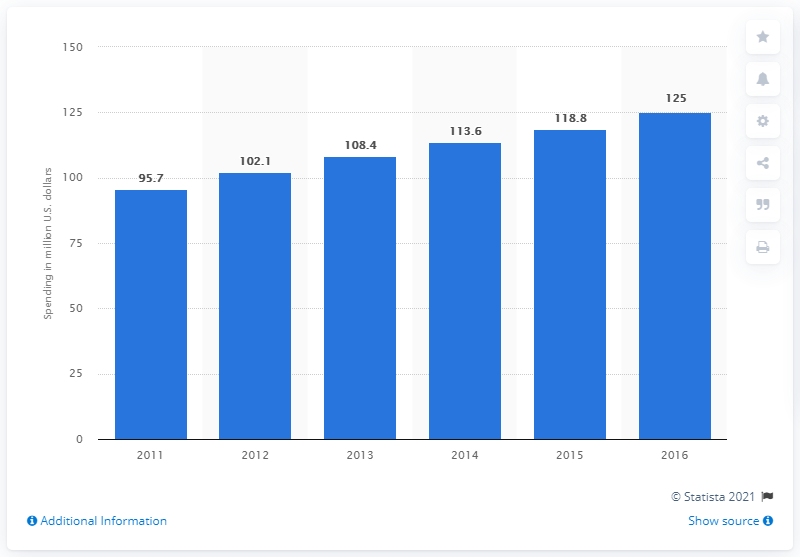Highlight a few significant elements in this photo. In 2013, the amount of global endurance sports sponsorship spending was 108.4 million U.S. dollars. 